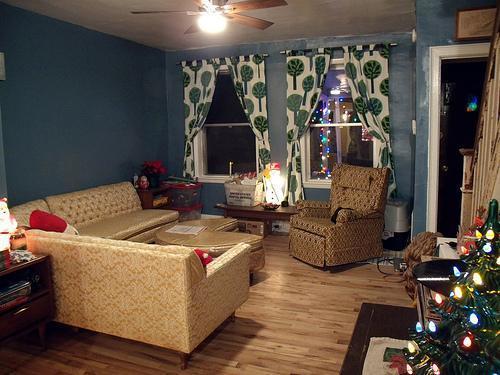How many of the curtains have stripes?
Give a very brief answer. 0. 